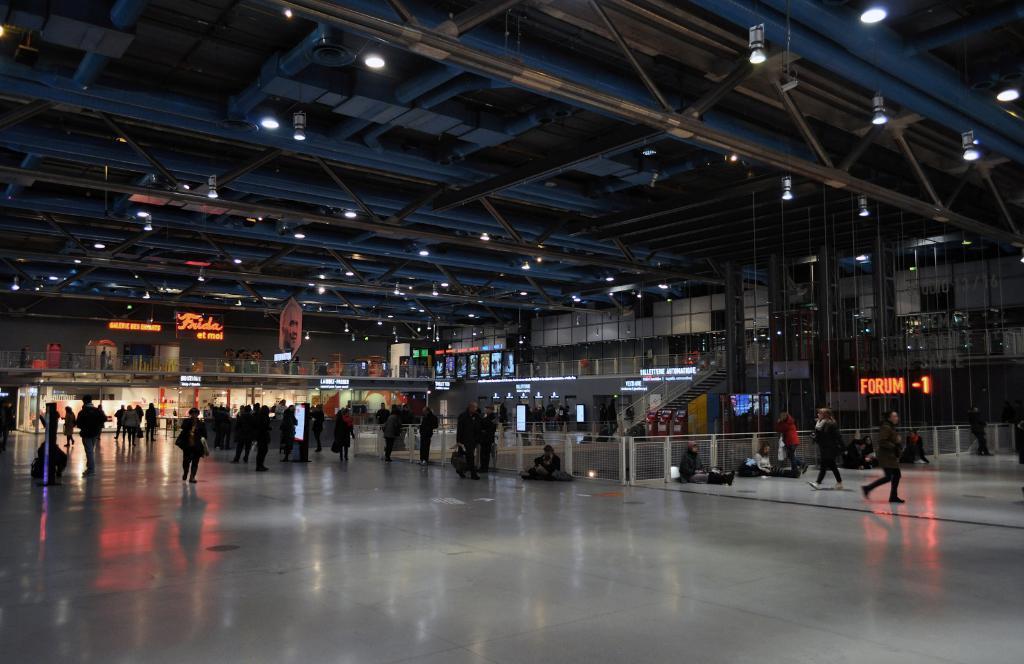Please provide a concise description of this image. Here in this picture we can see a group of people standing, walking and sitting on the floor present over there and on the roof we can see lights present all over there and we can see hoardings here and there and we can see a staircase present over there in the middle. 